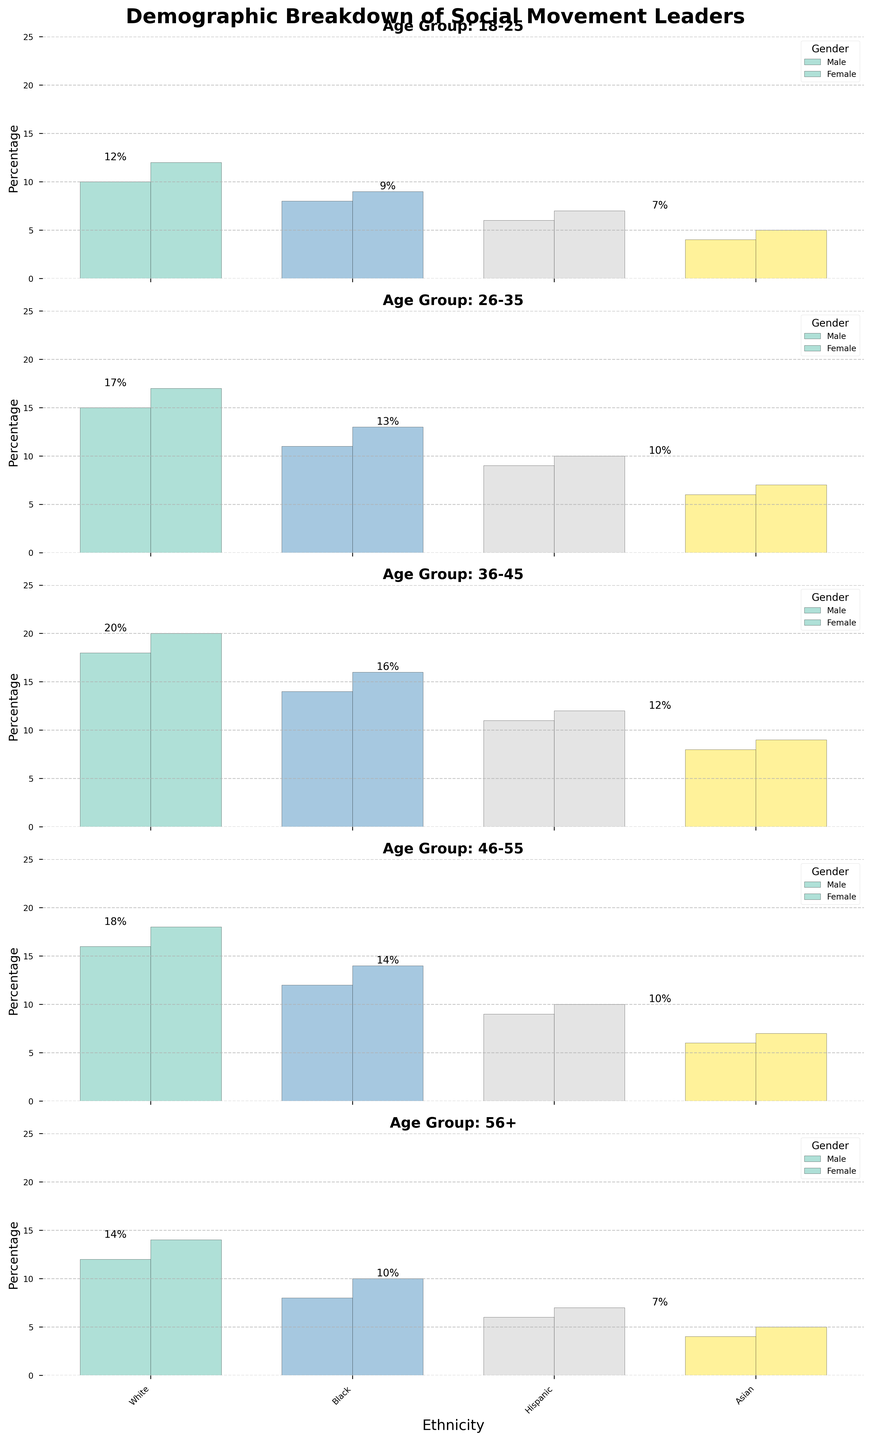Which age group has the highest percentage of female leaders? Observe the tallest female bars across all subplots. The 36-45 age group shows the highest female percentage with the white ethnic group having 20%.
Answer: 36-45 Which ethnicity has the lowest representation in the 56+ age group among males? Compare the heights of the male bars in the 56+ subplot. The Asian ethnicity has the lowest with 4%.
Answer: Asian What's the total percentage of Hispanic leaders in the 18-25 age group? Add the percentages of Hispanic leaders for both genders in the 18-25 subplot: 6% (Male) + 7% (Female) = 13%.
Answer: 13% Are there more Black female leaders in the 46-55 age group than Black male leaders in the 26-35 age group? Compare the heights of the Black female bar in the 46-55 subplot (14%) with the Black male bar in the 26-35 subplot (11%). Yes, 14% is greater than 11%.
Answer: Yes In the 26-35 age group, which gender has a higher percentage of Asian leaders? Compare the heights of the Asian bars for both genders in the 26-35 subplot. The female Asian bar is taller (7%) than the male Asian bar (6%).
Answer: Female Which age group shows a consistent pattern of having a higher percentage of female leaders compared to male leaders across all ethnicities? Examine each subplot to see where female bars are consistently taller than male bars across all ethnicities. The 36-45 age group shows this pattern.
Answer: 36-45 What is the difference in percentage between White female leaders and White male leaders in the 46-55 age group? Subtract the percentage of White male leaders from that of White female leaders in the 46-55 subplot: 18% - 16% = 2%.
Answer: 2% How does the percentage of Black leaders change from the 18-25 to the 56+ age group for both genders? Observe the heights of Black bars for both genders in the 18-25 subplot (8% for Males, 9% for Females) and in the 56+ subplot (8% for Males, 10% for Females). The percentage for males stays the same (8%), while it increases for females by 1% (9% to 10%).
Answer: M: same, F: +1% 